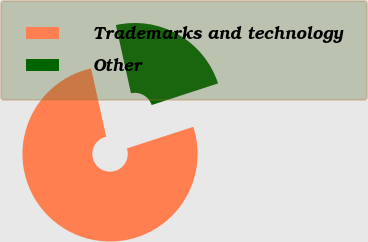<chart> <loc_0><loc_0><loc_500><loc_500><pie_chart><fcel>Trademarks and technology<fcel>Other<nl><fcel>76.54%<fcel>23.46%<nl></chart> 